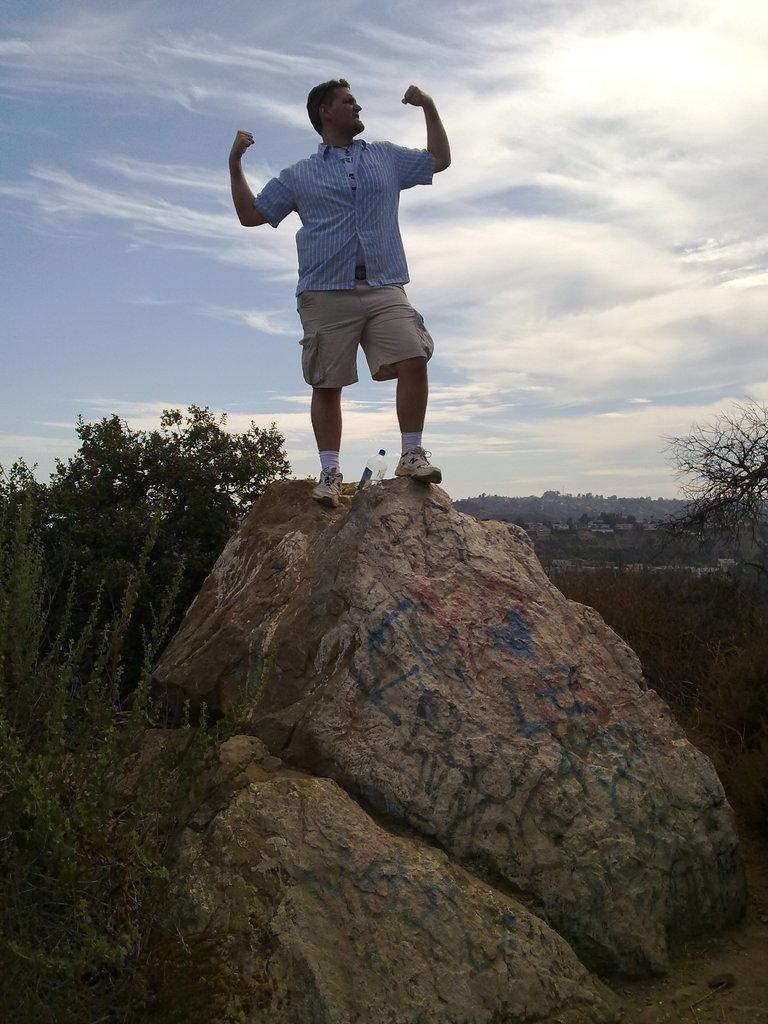What is the person in the image doing? The person is standing on a mountain in the image. What can be seen in the background of the image? Trees are visible in the background of the image. How would you describe the sky in the image? The sky is blue with clouds in the image. What type of muscle is being flexed by the person in the image? There is no indication in the image that the person is flexing any muscles, so it cannot be determined from the picture. 